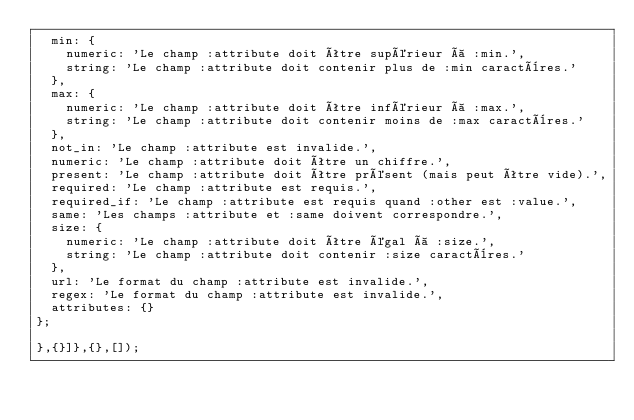Convert code to text. <code><loc_0><loc_0><loc_500><loc_500><_JavaScript_>  min: {
    numeric: 'Le champ :attribute doit être supérieur à :min.',
    string: 'Le champ :attribute doit contenir plus de :min caractères.'
  },
  max: {
    numeric: 'Le champ :attribute doit être inférieur à :max.',
    string: 'Le champ :attribute doit contenir moins de :max caractères.'
  },
  not_in: 'Le champ :attribute est invalide.',
  numeric: 'Le champ :attribute doit être un chiffre.',
  present: 'Le champ :attribute doit être présent (mais peut être vide).',
  required: 'Le champ :attribute est requis.',
  required_if: 'Le champ :attribute est requis quand :other est :value.',
  same: 'Les champs :attribute et :same doivent correspondre.',
  size: {
    numeric: 'Le champ :attribute doit être égal à :size.',
    string: 'Le champ :attribute doit contenir :size caractères.'
  },
  url: 'Le format du champ :attribute est invalide.',
  regex: 'Le format du champ :attribute est invalide.',
  attributes: {}
};

},{}]},{},[]);
</code> 